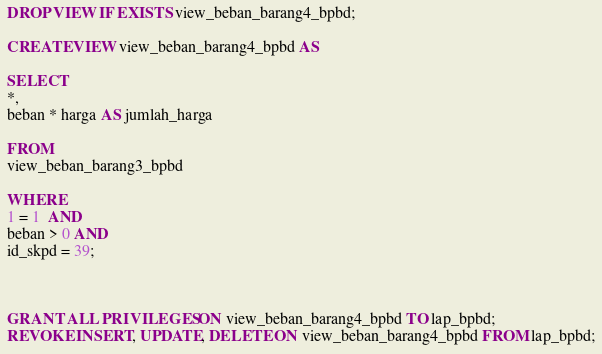Convert code to text. <code><loc_0><loc_0><loc_500><loc_500><_SQL_>DROP VIEW IF EXISTS view_beban_barang4_bpbd;

CREATE VIEW view_beban_barang4_bpbd AS

SELECT
*,
beban * harga AS jumlah_harga

FROM
view_beban_barang3_bpbd

WHERE
1 = 1  AND
beban > 0 AND
id_skpd = 39;



GRANT ALL PRIVILEGES ON view_beban_barang4_bpbd TO lap_bpbd;
REVOKE INSERT, UPDATE, DELETE ON view_beban_barang4_bpbd FROM lap_bpbd;
</code> 